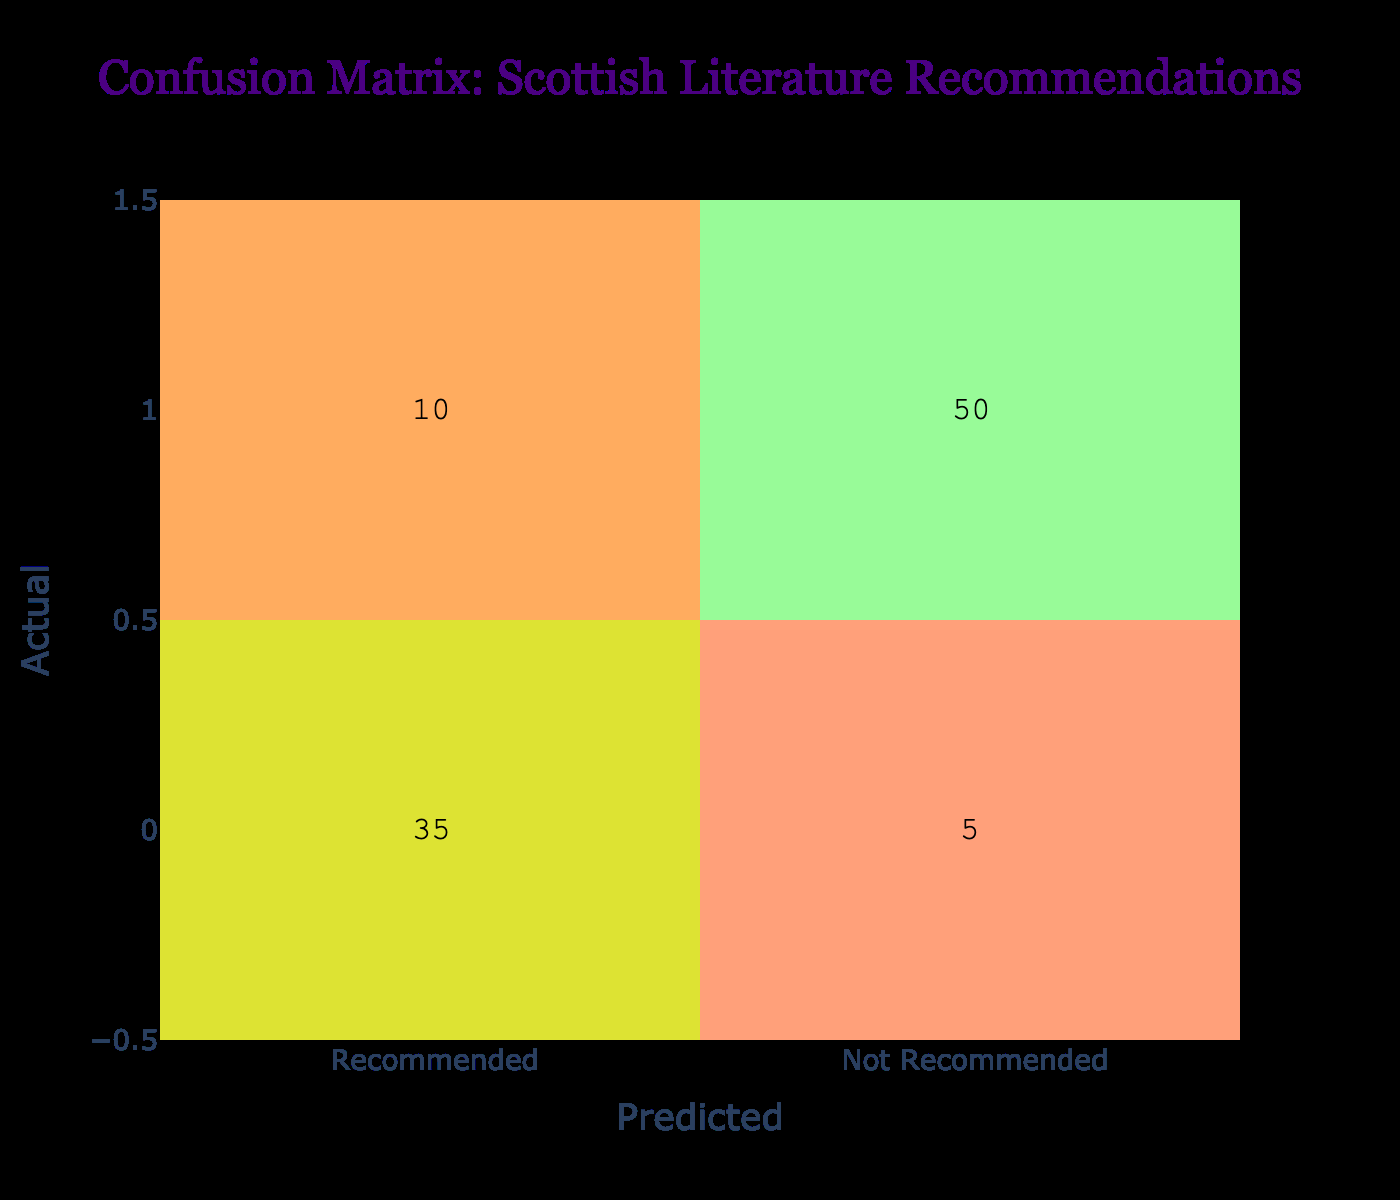What is the total number of recommendations? To find the total recommendations, we add the values in the "Recommended" column: 35 (true positives) + 10 (false negatives) = 45.
Answer: 45 How many users were correctly predicted to have recommended the books? The correctly predicted recommendations are given by the value in the top left of the matrix, which is 35 (true positives).
Answer: 35 What is the count of users who received a recommendation but did not recommend it? This corresponds to the bottom left cell in the matrix, which shows the false positives. The value there is 10.
Answer: 10 What percentage of actual recommendations were correctly classified as recommended? To find this percentage, we calculate (True Positives / Total Actual Recommendations) * 100. Total Actual Recommendations = 35 (TP) + 10 (FN) = 45, so (35/45) * 100 = 77.78%.
Answer: 77.78% Is it true that more people were not recommended than recommended? We can see from the values that 50 people (true negatives) were in the "Not Recommended" category, whereas 35 + 10 = 45 people were in the "Recommended" category. Thus, it is true.
Answer: Yes How many users were incorrectly predicted as recommending books? This is found in the bottom left cell of the matrix, indicating the false positives. It shows 10 users who were mislabeled as recommended when they did not.
Answer: 10 What is the total number of users who were predicted not to recommend the books? To calculate this, we sum the values in the "Not Recommended" column, which include both true negatives and false negatives: 5 (false negatives) + 50 (true negatives) = 55 users.
Answer: 55 If 5 users were wrongly predicted as recommended, what is the error rate for that prediction? The error rate is calculated as (False Positives / Total Predicted Recommendations) * 100. Total Predicted Recommendations = 35 (TP) + 5 (FP) = 40, thus (5/40) * 100 = 12.5%.
Answer: 12.5% How many users were correctly classified as not recommending the books? This corresponds to the value in the bottom right of the matrix, which shows 50 true negatives.
Answer: 50 